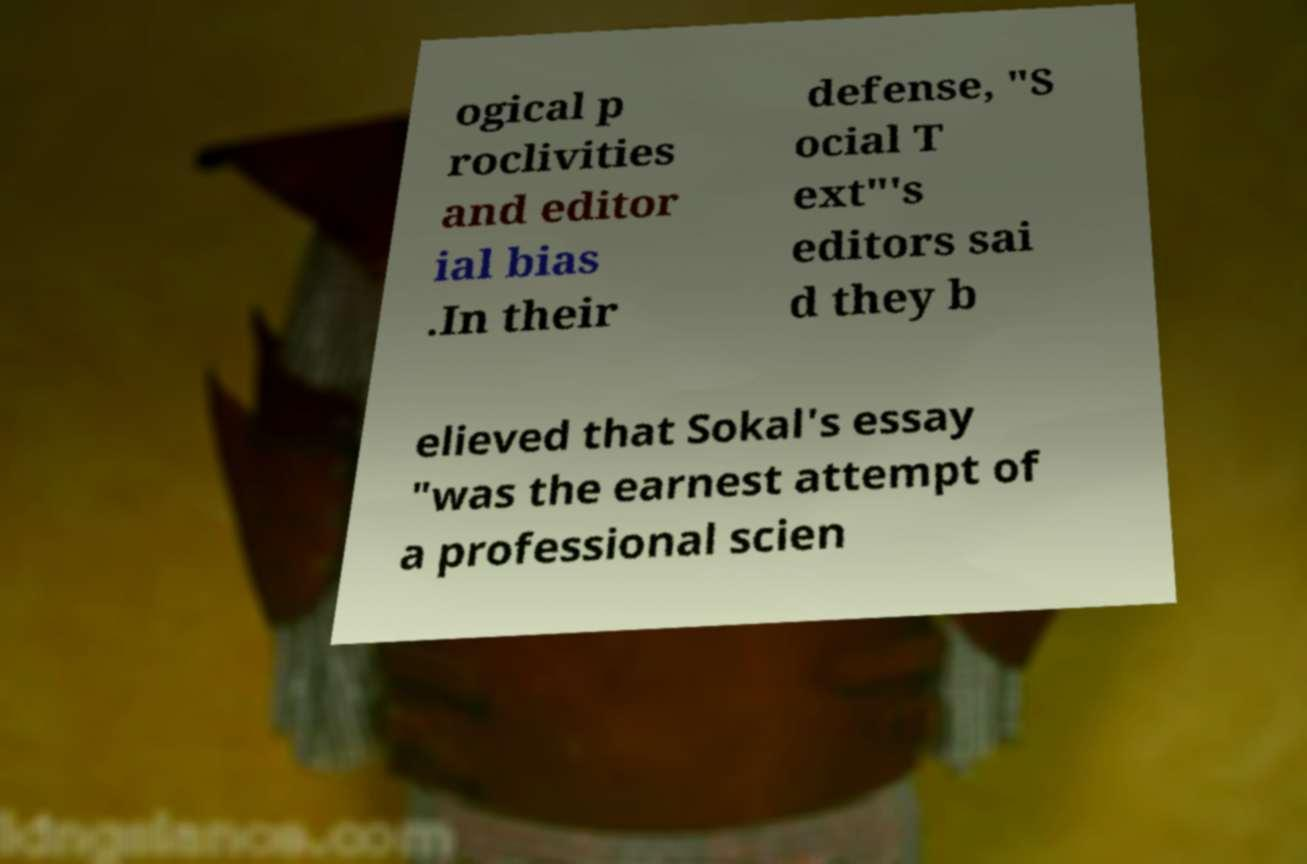What messages or text are displayed in this image? I need them in a readable, typed format. ogical p roclivities and editor ial bias .In their defense, "S ocial T ext"'s editors sai d they b elieved that Sokal's essay "was the earnest attempt of a professional scien 